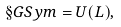<formula> <loc_0><loc_0><loc_500><loc_500>\S G S y m = U ( L ) ,</formula> 